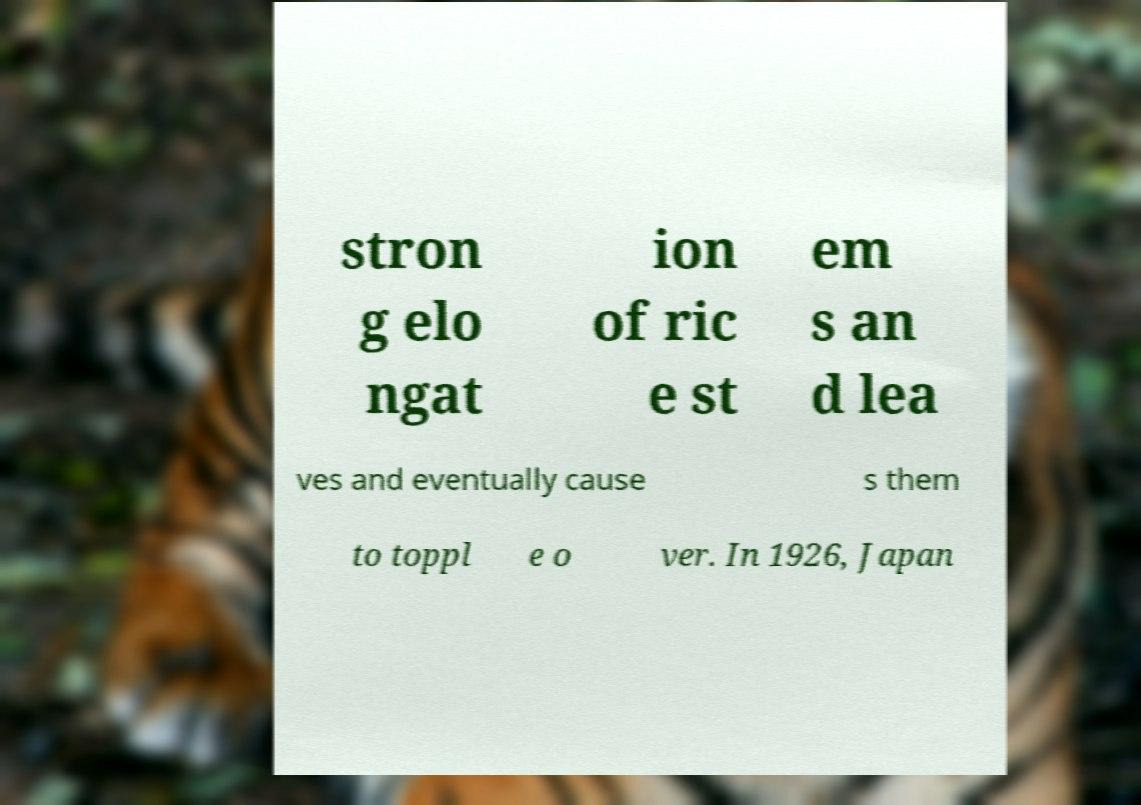Can you read and provide the text displayed in the image?This photo seems to have some interesting text. Can you extract and type it out for me? stron g elo ngat ion of ric e st em s an d lea ves and eventually cause s them to toppl e o ver. In 1926, Japan 